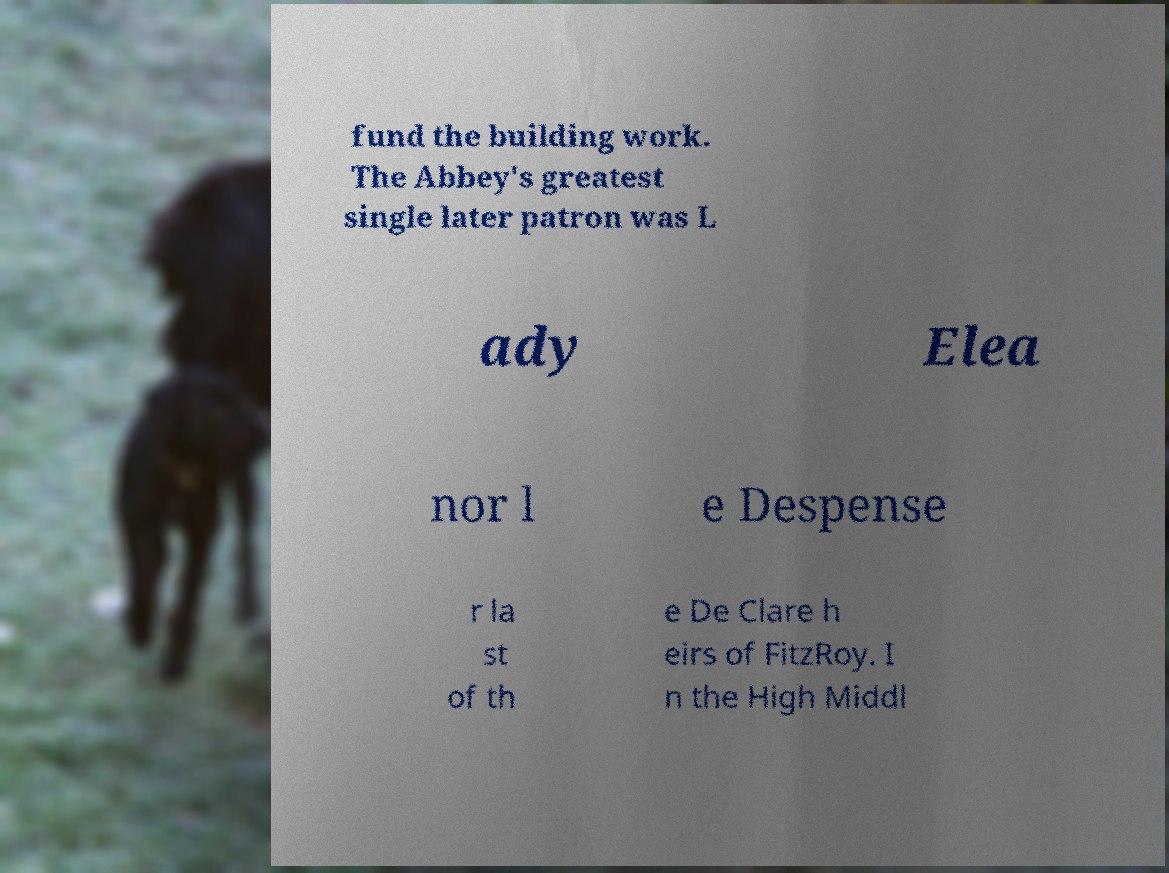For documentation purposes, I need the text within this image transcribed. Could you provide that? fund the building work. The Abbey's greatest single later patron was L ady Elea nor l e Despense r la st of th e De Clare h eirs of FitzRoy. I n the High Middl 